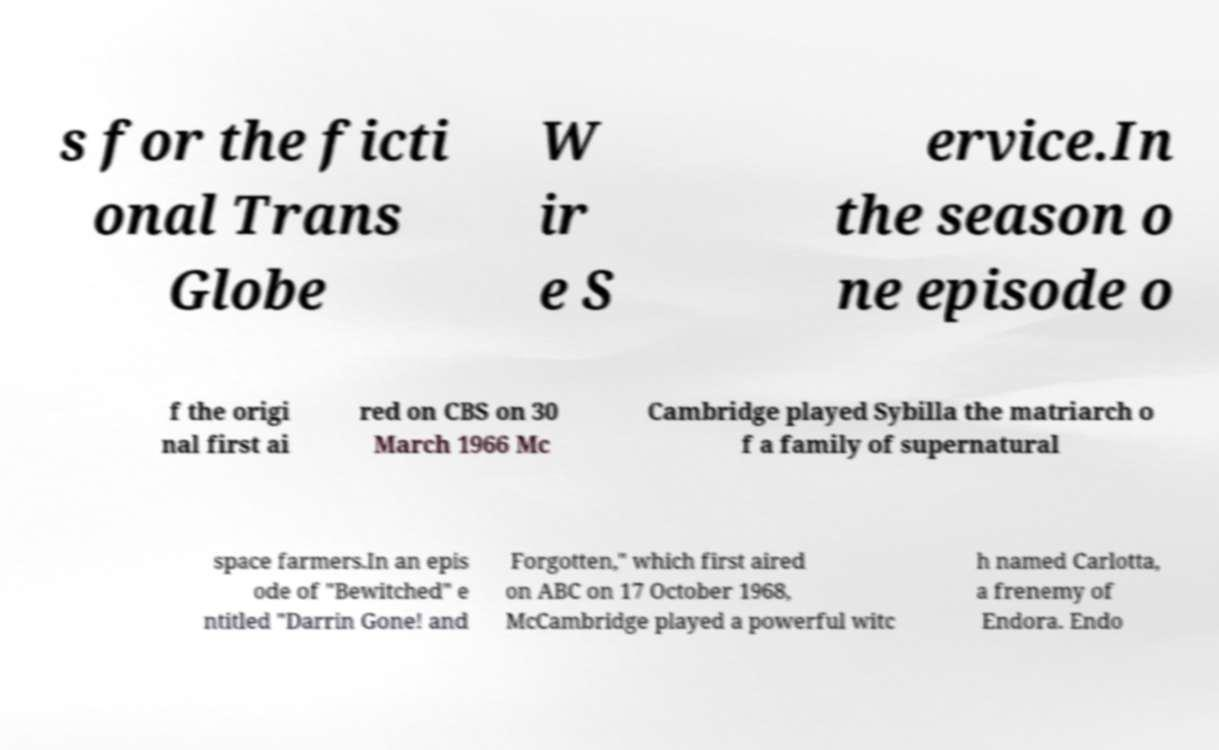Could you extract and type out the text from this image? s for the ficti onal Trans Globe W ir e S ervice.In the season o ne episode o f the origi nal first ai red on CBS on 30 March 1966 Mc Cambridge played Sybilla the matriarch o f a family of supernatural space farmers.In an epis ode of "Bewitched" e ntitled "Darrin Gone! and Forgotten," which first aired on ABC on 17 October 1968, McCambridge played a powerful witc h named Carlotta, a frenemy of Endora. Endo 